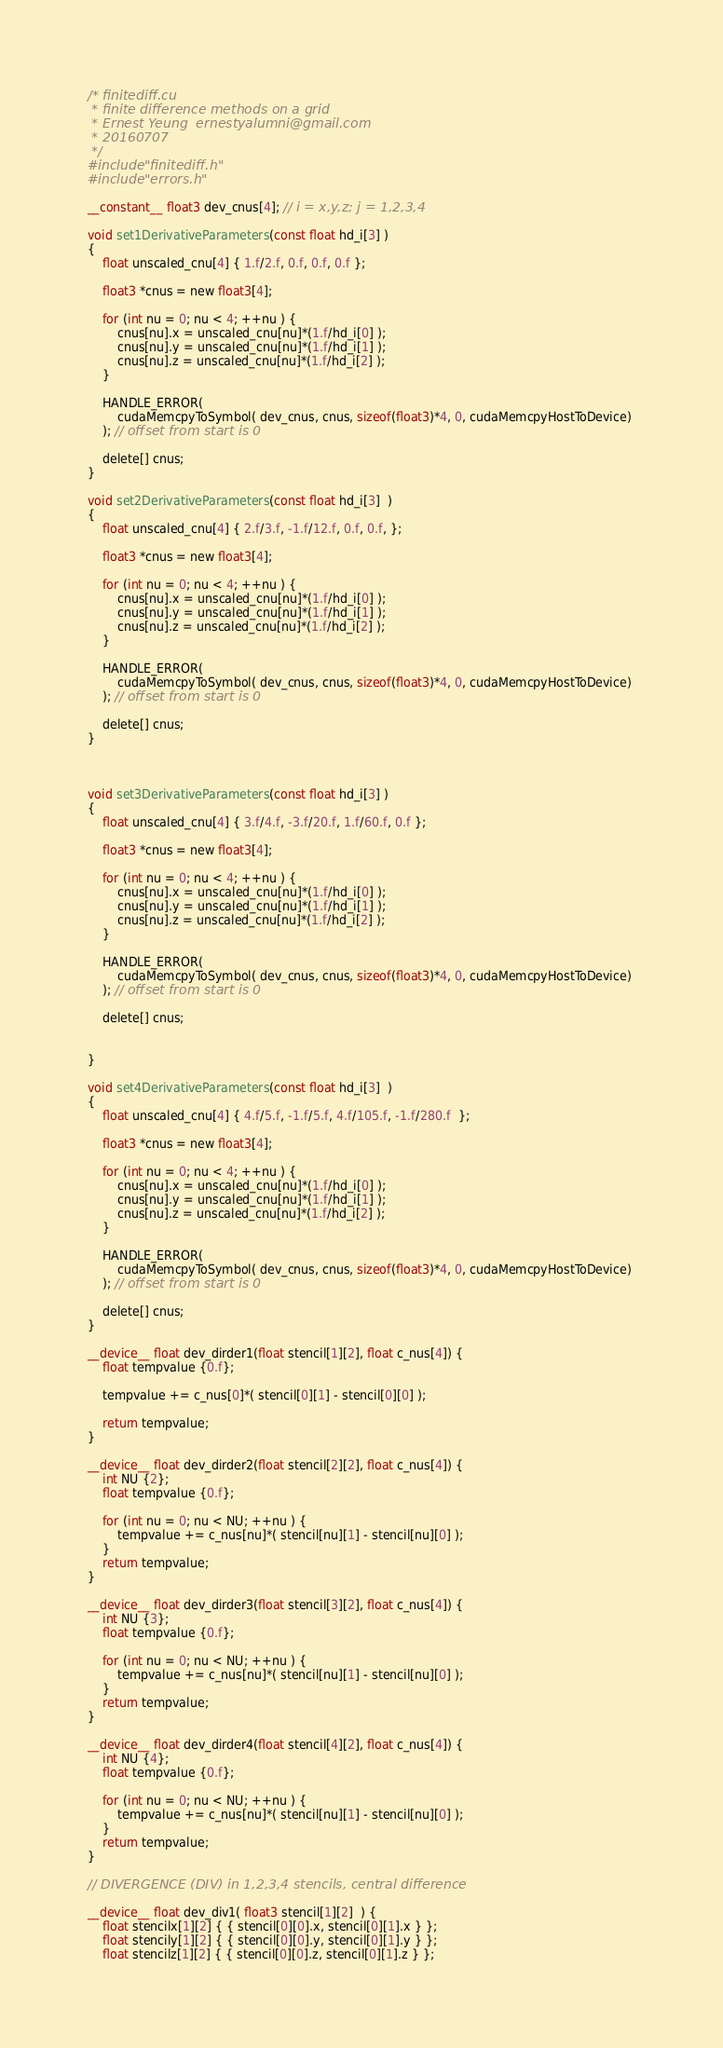Convert code to text. <code><loc_0><loc_0><loc_500><loc_500><_Cuda_>/* finitediff.cu
 * finite difference methods on a grid
 * Ernest Yeung  ernestyalumni@gmail.com
 * 20160707
 */
#include "finitediff.h"
#include "errors.h"

__constant__ float3 dev_cnus[4]; // i = x,y,z; j = 1,2,3,4

void set1DerivativeParameters(const float hd_i[3] )
{
	float unscaled_cnu[4] { 1.f/2.f, 0.f, 0.f, 0.f };
	
	float3 *cnus = new float3[4];

	for (int nu = 0; nu < 4; ++nu ) {
		cnus[nu].x = unscaled_cnu[nu]*(1.f/hd_i[0] );
		cnus[nu].y = unscaled_cnu[nu]*(1.f/hd_i[1] );
		cnus[nu].z = unscaled_cnu[nu]*(1.f/hd_i[2] );
	}
	
	HANDLE_ERROR(
		cudaMemcpyToSymbol( dev_cnus, cnus, sizeof(float3)*4, 0, cudaMemcpyHostToDevice) 
	); // offset from start is 0
	
	delete[] cnus;		
}

void set2DerivativeParameters(const float hd_i[3]  )
{
	float unscaled_cnu[4] { 2.f/3.f, -1.f/12.f, 0.f, 0.f, };
	
	float3 *cnus = new float3[4];

	for (int nu = 0; nu < 4; ++nu ) {
		cnus[nu].x = unscaled_cnu[nu]*(1.f/hd_i[0] );
		cnus[nu].y = unscaled_cnu[nu]*(1.f/hd_i[1] );
		cnus[nu].z = unscaled_cnu[nu]*(1.f/hd_i[2] );
	}
	
	HANDLE_ERROR(
		cudaMemcpyToSymbol( dev_cnus, cnus, sizeof(float3)*4, 0, cudaMemcpyHostToDevice) 
	); // offset from start is 0
	
	delete[] cnus;		
}



void set3DerivativeParameters(const float hd_i[3] )
{
	float unscaled_cnu[4] { 3.f/4.f, -3.f/20.f, 1.f/60.f, 0.f };
	
	float3 *cnus = new float3[4];

	for (int nu = 0; nu < 4; ++nu ) {
		cnus[nu].x = unscaled_cnu[nu]*(1.f/hd_i[0] );
		cnus[nu].y = unscaled_cnu[nu]*(1.f/hd_i[1] );
		cnus[nu].z = unscaled_cnu[nu]*(1.f/hd_i[2] );
	}
	
	HANDLE_ERROR(
		cudaMemcpyToSymbol( dev_cnus, cnus, sizeof(float3)*4, 0, cudaMemcpyHostToDevice) 
	); // offset from start is 0
	
	delete[] cnus;		

		
}

void set4DerivativeParameters(const float hd_i[3]  )
{
	float unscaled_cnu[4] { 4.f/5.f, -1.f/5.f, 4.f/105.f, -1.f/280.f  };
	
	float3 *cnus = new float3[4];

	for (int nu = 0; nu < 4; ++nu ) {
		cnus[nu].x = unscaled_cnu[nu]*(1.f/hd_i[0] );
		cnus[nu].y = unscaled_cnu[nu]*(1.f/hd_i[1] );
		cnus[nu].z = unscaled_cnu[nu]*(1.f/hd_i[2] );
	}
	
	HANDLE_ERROR(
		cudaMemcpyToSymbol( dev_cnus, cnus, sizeof(float3)*4, 0, cudaMemcpyHostToDevice) 
	); // offset from start is 0
	
	delete[] cnus;		
}

__device__ float dev_dirder1(float stencil[1][2], float c_nus[4]) {
	float tempvalue {0.f};

	tempvalue += c_nus[0]*( stencil[0][1] - stencil[0][0] );

	return tempvalue;
}

__device__ float dev_dirder2(float stencil[2][2], float c_nus[4]) {
	int NU {2};
	float tempvalue {0.f};

	for (int nu = 0; nu < NU; ++nu ) {
		tempvalue += c_nus[nu]*( stencil[nu][1] - stencil[nu][0] );
	}
	return tempvalue;
}

__device__ float dev_dirder3(float stencil[3][2], float c_nus[4]) {
	int NU {3};
	float tempvalue {0.f};
		
	for (int nu = 0; nu < NU; ++nu ) {
		tempvalue += c_nus[nu]*( stencil[nu][1] - stencil[nu][0] );
	}
	return tempvalue;
}

__device__ float dev_dirder4(float stencil[4][2], float c_nus[4]) {
	int NU {4};
	float tempvalue {0.f};

	for (int nu = 0; nu < NU; ++nu ) {
		tempvalue += c_nus[nu]*( stencil[nu][1] - stencil[nu][0] );
	}
	return tempvalue;
}

// DIVERGENCE (DIV) in 1,2,3,4 stencils, central difference

__device__ float dev_div1( float3 stencil[1][2]  ) {
	float stencilx[1][2] { { stencil[0][0].x, stencil[0][1].x } };
	float stencily[1][2] { { stencil[0][0].y, stencil[0][1].y } };
	float stencilz[1][2] { { stencil[0][0].z, stencil[0][1].z } };
</code> 